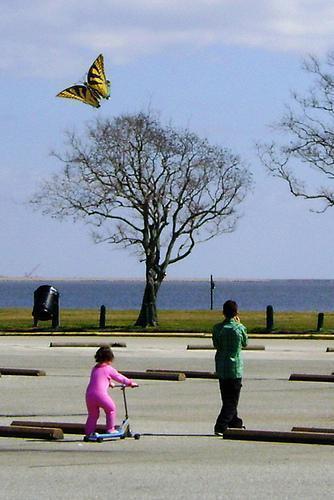The kite here is designed to resemble what?
Make your selection and explain in format: 'Answer: answer
Rationale: rationale.'
Options: Butterfly, house fly, dog, bird. Answer: butterfly.
Rationale: The kite looks like a butterfly. 